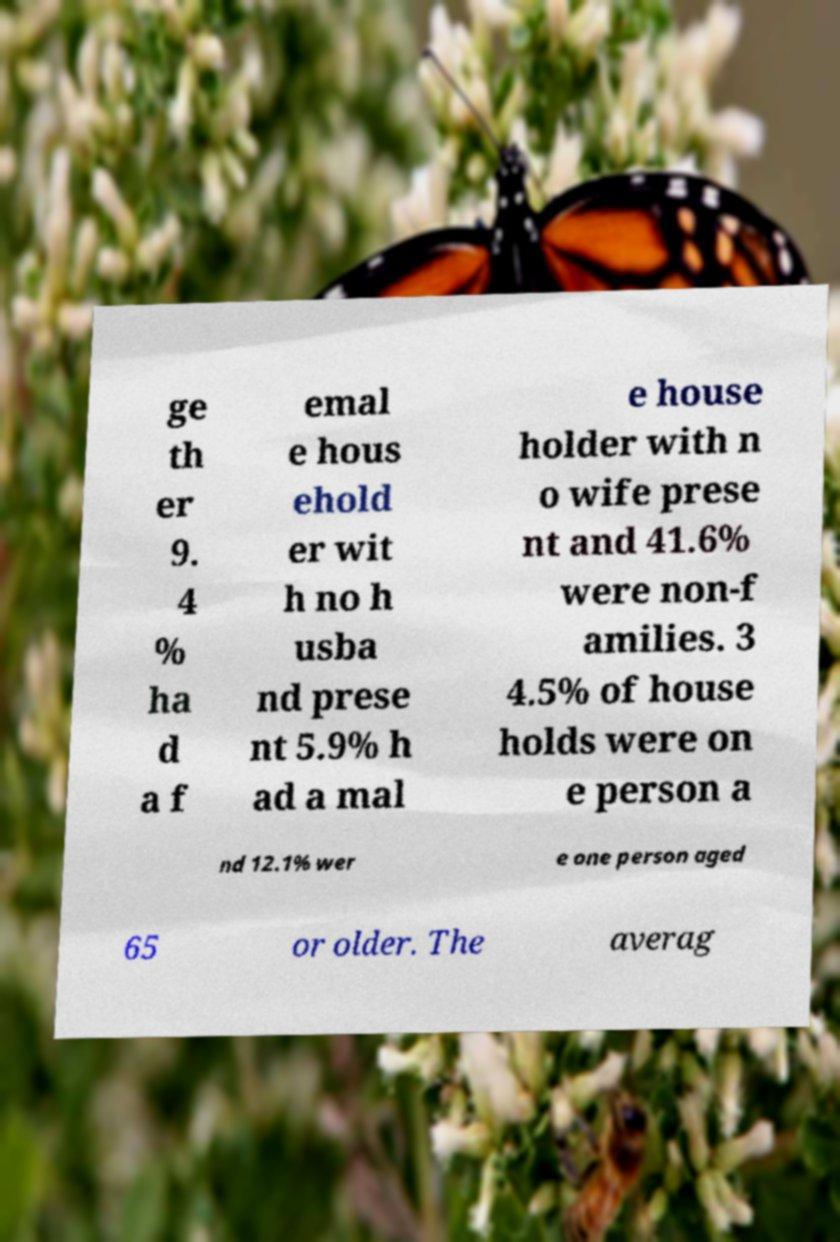Could you extract and type out the text from this image? ge th er 9. 4 % ha d a f emal e hous ehold er wit h no h usba nd prese nt 5.9% h ad a mal e house holder with n o wife prese nt and 41.6% were non-f amilies. 3 4.5% of house holds were on e person a nd 12.1% wer e one person aged 65 or older. The averag 